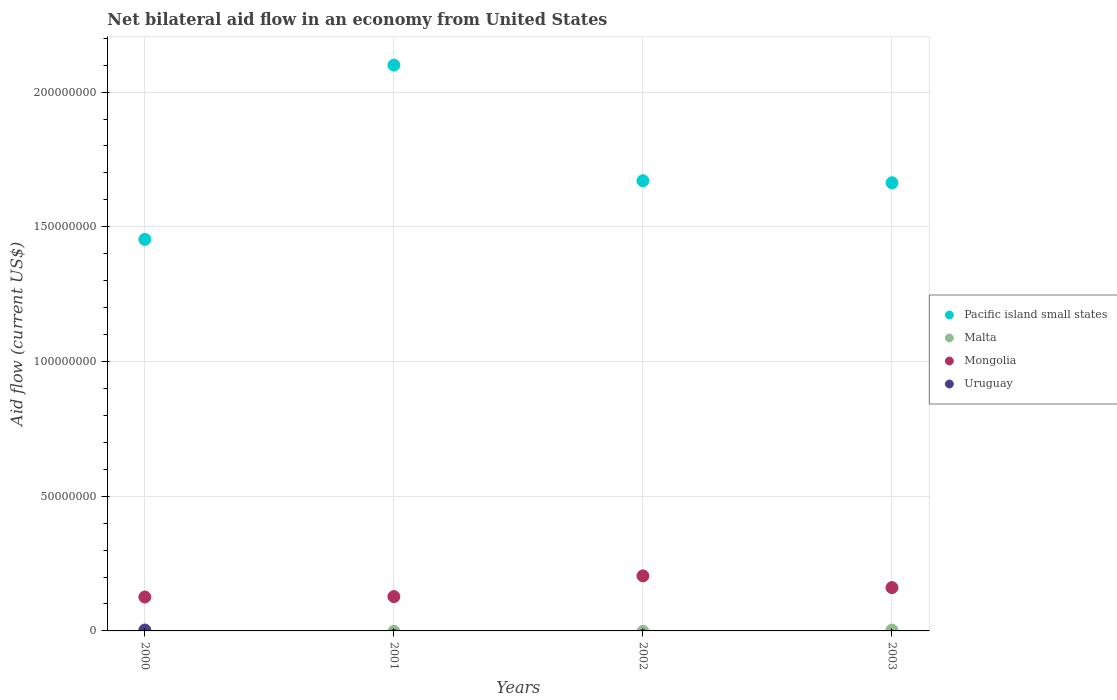How many different coloured dotlines are there?
Offer a very short reply. 4. What is the net bilateral aid flow in Mongolia in 2003?
Keep it short and to the point. 1.61e+07. Across all years, what is the maximum net bilateral aid flow in Pacific island small states?
Provide a short and direct response. 2.10e+08. Across all years, what is the minimum net bilateral aid flow in Malta?
Give a very brief answer. 0. In which year was the net bilateral aid flow in Mongolia maximum?
Your answer should be very brief. 2002. What is the difference between the net bilateral aid flow in Pacific island small states in 2000 and that in 2002?
Provide a succinct answer. -2.18e+07. What is the difference between the net bilateral aid flow in Uruguay in 2002 and the net bilateral aid flow in Pacific island small states in 2001?
Give a very brief answer. -2.10e+08. What is the average net bilateral aid flow in Uruguay per year?
Your answer should be compact. 8.50e+04. In the year 2003, what is the difference between the net bilateral aid flow in Malta and net bilateral aid flow in Pacific island small states?
Provide a succinct answer. -1.66e+08. In how many years, is the net bilateral aid flow in Uruguay greater than 190000000 US$?
Offer a very short reply. 0. What is the ratio of the net bilateral aid flow in Pacific island small states in 2000 to that in 2001?
Offer a very short reply. 0.69. What is the difference between the highest and the second highest net bilateral aid flow in Pacific island small states?
Your answer should be compact. 4.29e+07. What is the difference between the highest and the lowest net bilateral aid flow in Uruguay?
Ensure brevity in your answer.  3.40e+05. In how many years, is the net bilateral aid flow in Malta greater than the average net bilateral aid flow in Malta taken over all years?
Ensure brevity in your answer.  1. Does the net bilateral aid flow in Mongolia monotonically increase over the years?
Give a very brief answer. No. Is the net bilateral aid flow in Mongolia strictly greater than the net bilateral aid flow in Uruguay over the years?
Your answer should be very brief. Yes. What is the difference between two consecutive major ticks on the Y-axis?
Offer a very short reply. 5.00e+07. Are the values on the major ticks of Y-axis written in scientific E-notation?
Your answer should be compact. No. Does the graph contain grids?
Your answer should be very brief. Yes. Where does the legend appear in the graph?
Keep it short and to the point. Center right. How are the legend labels stacked?
Give a very brief answer. Vertical. What is the title of the graph?
Offer a very short reply. Net bilateral aid flow in an economy from United States. Does "Virgin Islands" appear as one of the legend labels in the graph?
Offer a terse response. No. What is the label or title of the X-axis?
Give a very brief answer. Years. What is the Aid flow (current US$) of Pacific island small states in 2000?
Give a very brief answer. 1.45e+08. What is the Aid flow (current US$) in Malta in 2000?
Make the answer very short. 0. What is the Aid flow (current US$) of Mongolia in 2000?
Offer a very short reply. 1.26e+07. What is the Aid flow (current US$) of Uruguay in 2000?
Your answer should be compact. 3.40e+05. What is the Aid flow (current US$) in Pacific island small states in 2001?
Offer a very short reply. 2.10e+08. What is the Aid flow (current US$) of Malta in 2001?
Give a very brief answer. 0. What is the Aid flow (current US$) in Mongolia in 2001?
Ensure brevity in your answer.  1.27e+07. What is the Aid flow (current US$) of Pacific island small states in 2002?
Provide a succinct answer. 1.67e+08. What is the Aid flow (current US$) in Malta in 2002?
Offer a terse response. 0. What is the Aid flow (current US$) in Mongolia in 2002?
Ensure brevity in your answer.  2.04e+07. What is the Aid flow (current US$) of Uruguay in 2002?
Give a very brief answer. 0. What is the Aid flow (current US$) in Pacific island small states in 2003?
Ensure brevity in your answer.  1.66e+08. What is the Aid flow (current US$) in Mongolia in 2003?
Offer a terse response. 1.61e+07. What is the Aid flow (current US$) of Uruguay in 2003?
Provide a succinct answer. 0. Across all years, what is the maximum Aid flow (current US$) in Pacific island small states?
Your response must be concise. 2.10e+08. Across all years, what is the maximum Aid flow (current US$) in Mongolia?
Provide a succinct answer. 2.04e+07. Across all years, what is the maximum Aid flow (current US$) of Uruguay?
Ensure brevity in your answer.  3.40e+05. Across all years, what is the minimum Aid flow (current US$) in Pacific island small states?
Provide a succinct answer. 1.45e+08. Across all years, what is the minimum Aid flow (current US$) in Mongolia?
Offer a terse response. 1.26e+07. Across all years, what is the minimum Aid flow (current US$) of Uruguay?
Your response must be concise. 0. What is the total Aid flow (current US$) of Pacific island small states in the graph?
Give a very brief answer. 6.89e+08. What is the total Aid flow (current US$) in Malta in the graph?
Give a very brief answer. 3.10e+05. What is the total Aid flow (current US$) in Mongolia in the graph?
Make the answer very short. 6.18e+07. What is the difference between the Aid flow (current US$) in Pacific island small states in 2000 and that in 2001?
Ensure brevity in your answer.  -6.47e+07. What is the difference between the Aid flow (current US$) in Mongolia in 2000 and that in 2001?
Make the answer very short. -1.50e+05. What is the difference between the Aid flow (current US$) in Pacific island small states in 2000 and that in 2002?
Offer a terse response. -2.18e+07. What is the difference between the Aid flow (current US$) in Mongolia in 2000 and that in 2002?
Keep it short and to the point. -7.84e+06. What is the difference between the Aid flow (current US$) of Pacific island small states in 2000 and that in 2003?
Offer a very short reply. -2.10e+07. What is the difference between the Aid flow (current US$) in Mongolia in 2000 and that in 2003?
Offer a terse response. -3.49e+06. What is the difference between the Aid flow (current US$) in Pacific island small states in 2001 and that in 2002?
Make the answer very short. 4.29e+07. What is the difference between the Aid flow (current US$) of Mongolia in 2001 and that in 2002?
Your response must be concise. -7.69e+06. What is the difference between the Aid flow (current US$) of Pacific island small states in 2001 and that in 2003?
Provide a short and direct response. 4.37e+07. What is the difference between the Aid flow (current US$) of Mongolia in 2001 and that in 2003?
Ensure brevity in your answer.  -3.34e+06. What is the difference between the Aid flow (current US$) of Pacific island small states in 2002 and that in 2003?
Provide a succinct answer. 7.50e+05. What is the difference between the Aid flow (current US$) in Mongolia in 2002 and that in 2003?
Ensure brevity in your answer.  4.35e+06. What is the difference between the Aid flow (current US$) in Pacific island small states in 2000 and the Aid flow (current US$) in Mongolia in 2001?
Your response must be concise. 1.33e+08. What is the difference between the Aid flow (current US$) of Pacific island small states in 2000 and the Aid flow (current US$) of Mongolia in 2002?
Keep it short and to the point. 1.25e+08. What is the difference between the Aid flow (current US$) in Pacific island small states in 2000 and the Aid flow (current US$) in Malta in 2003?
Offer a terse response. 1.45e+08. What is the difference between the Aid flow (current US$) in Pacific island small states in 2000 and the Aid flow (current US$) in Mongolia in 2003?
Provide a succinct answer. 1.29e+08. What is the difference between the Aid flow (current US$) of Pacific island small states in 2001 and the Aid flow (current US$) of Mongolia in 2002?
Ensure brevity in your answer.  1.90e+08. What is the difference between the Aid flow (current US$) in Pacific island small states in 2001 and the Aid flow (current US$) in Malta in 2003?
Provide a succinct answer. 2.10e+08. What is the difference between the Aid flow (current US$) of Pacific island small states in 2001 and the Aid flow (current US$) of Mongolia in 2003?
Provide a succinct answer. 1.94e+08. What is the difference between the Aid flow (current US$) in Pacific island small states in 2002 and the Aid flow (current US$) in Malta in 2003?
Make the answer very short. 1.67e+08. What is the difference between the Aid flow (current US$) in Pacific island small states in 2002 and the Aid flow (current US$) in Mongolia in 2003?
Offer a terse response. 1.51e+08. What is the average Aid flow (current US$) in Pacific island small states per year?
Your answer should be compact. 1.72e+08. What is the average Aid flow (current US$) of Malta per year?
Ensure brevity in your answer.  7.75e+04. What is the average Aid flow (current US$) of Mongolia per year?
Give a very brief answer. 1.55e+07. What is the average Aid flow (current US$) of Uruguay per year?
Make the answer very short. 8.50e+04. In the year 2000, what is the difference between the Aid flow (current US$) of Pacific island small states and Aid flow (current US$) of Mongolia?
Ensure brevity in your answer.  1.33e+08. In the year 2000, what is the difference between the Aid flow (current US$) of Pacific island small states and Aid flow (current US$) of Uruguay?
Your response must be concise. 1.45e+08. In the year 2000, what is the difference between the Aid flow (current US$) in Mongolia and Aid flow (current US$) in Uruguay?
Provide a short and direct response. 1.22e+07. In the year 2001, what is the difference between the Aid flow (current US$) in Pacific island small states and Aid flow (current US$) in Mongolia?
Ensure brevity in your answer.  1.97e+08. In the year 2002, what is the difference between the Aid flow (current US$) of Pacific island small states and Aid flow (current US$) of Mongolia?
Provide a short and direct response. 1.47e+08. In the year 2003, what is the difference between the Aid flow (current US$) in Pacific island small states and Aid flow (current US$) in Malta?
Your answer should be very brief. 1.66e+08. In the year 2003, what is the difference between the Aid flow (current US$) in Pacific island small states and Aid flow (current US$) in Mongolia?
Your answer should be compact. 1.50e+08. In the year 2003, what is the difference between the Aid flow (current US$) of Malta and Aid flow (current US$) of Mongolia?
Provide a short and direct response. -1.58e+07. What is the ratio of the Aid flow (current US$) in Pacific island small states in 2000 to that in 2001?
Your response must be concise. 0.69. What is the ratio of the Aid flow (current US$) in Pacific island small states in 2000 to that in 2002?
Give a very brief answer. 0.87. What is the ratio of the Aid flow (current US$) of Mongolia in 2000 to that in 2002?
Offer a terse response. 0.62. What is the ratio of the Aid flow (current US$) in Pacific island small states in 2000 to that in 2003?
Give a very brief answer. 0.87. What is the ratio of the Aid flow (current US$) of Mongolia in 2000 to that in 2003?
Keep it short and to the point. 0.78. What is the ratio of the Aid flow (current US$) of Pacific island small states in 2001 to that in 2002?
Ensure brevity in your answer.  1.26. What is the ratio of the Aid flow (current US$) in Mongolia in 2001 to that in 2002?
Provide a short and direct response. 0.62. What is the ratio of the Aid flow (current US$) in Pacific island small states in 2001 to that in 2003?
Offer a terse response. 1.26. What is the ratio of the Aid flow (current US$) in Mongolia in 2001 to that in 2003?
Keep it short and to the point. 0.79. What is the ratio of the Aid flow (current US$) in Mongolia in 2002 to that in 2003?
Your response must be concise. 1.27. What is the difference between the highest and the second highest Aid flow (current US$) in Pacific island small states?
Your answer should be very brief. 4.29e+07. What is the difference between the highest and the second highest Aid flow (current US$) in Mongolia?
Provide a succinct answer. 4.35e+06. What is the difference between the highest and the lowest Aid flow (current US$) of Pacific island small states?
Give a very brief answer. 6.47e+07. What is the difference between the highest and the lowest Aid flow (current US$) in Mongolia?
Offer a very short reply. 7.84e+06. What is the difference between the highest and the lowest Aid flow (current US$) of Uruguay?
Provide a short and direct response. 3.40e+05. 